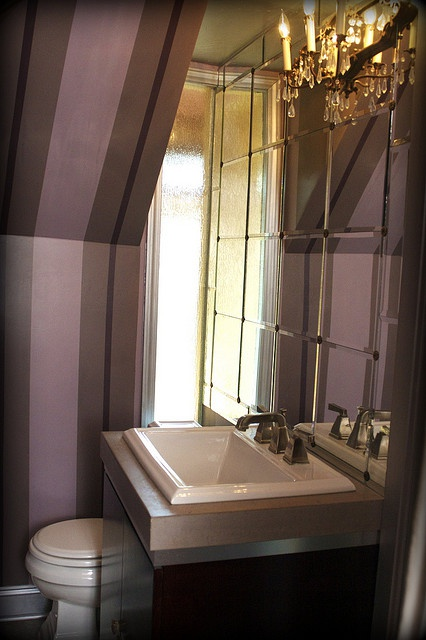Describe the objects in this image and their specific colors. I can see sink in black, gray, and darkgray tones and toilet in black, gray, and darkgray tones in this image. 